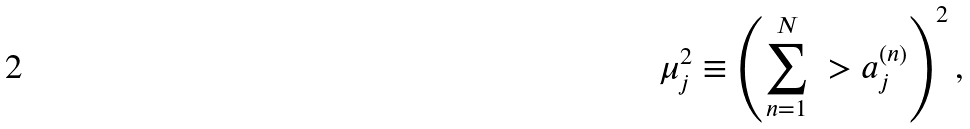<formula> <loc_0><loc_0><loc_500><loc_500>\mu _ { j } ^ { 2 } \equiv \left ( \sum _ { n = 1 } ^ { N } \ > a _ { j } ^ { ( n ) } \right ) ^ { 2 } ,</formula> 